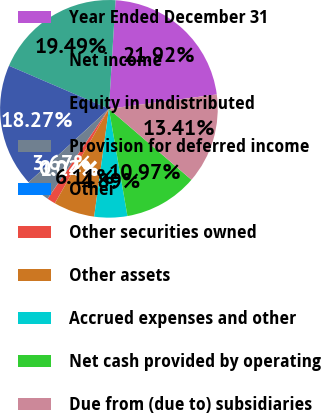<chart> <loc_0><loc_0><loc_500><loc_500><pie_chart><fcel>Year Ended December 31<fcel>Net income<fcel>Equity in undistributed<fcel>Provision for deferred income<fcel>Other<fcel>Other securities owned<fcel>Other assets<fcel>Accrued expenses and other<fcel>Net cash provided by operating<fcel>Due from (due to) subsidiaries<nl><fcel>21.92%<fcel>19.49%<fcel>18.27%<fcel>3.67%<fcel>0.02%<fcel>1.24%<fcel>6.11%<fcel>4.89%<fcel>10.97%<fcel>13.41%<nl></chart> 